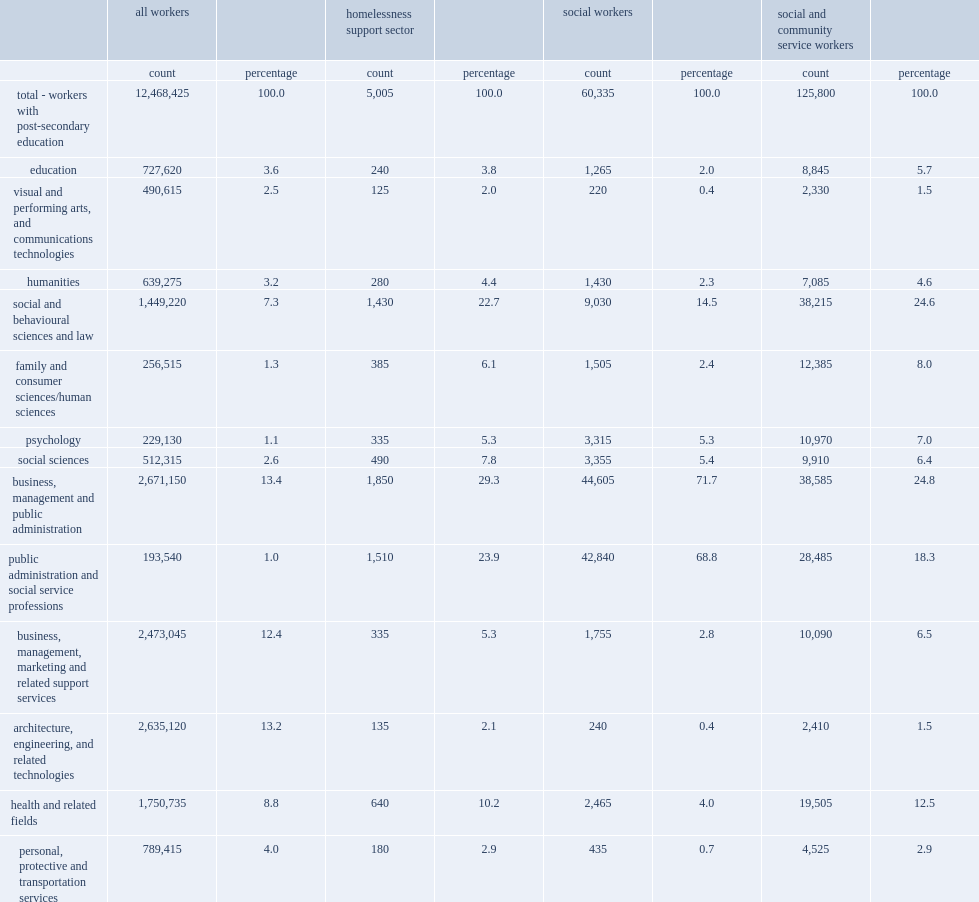How many employees were in homelessness support sector with post-secondary education? 5005.0. What was the proportion of employees in the homelessness support sector that reported their major filed of study as business, management and public administration? 29.3. What was the proportion of employees in the homelessness support sector that reported studying fields related to public administration and social service professions? 23.9. What was the proportion of homelessness support sector workers that reported studying social and behavioural sciences and law? 22.7. What was the proportion of social workers that reported business, management and public administration as their major field of study? 71.7. What was the proportion of social workers that reported social and behavioural sciences and law as their major field of study? 14.5. What was the proportion of social and community service workers reported their major field of study as social and behavioural sciences and law? 24.6. What was the proportion of social and community service workers reported their major field of study as business, management and public administration? 24.8. What was the proportion of social and community service workers reported their major field of study as health and related fields? 12.5. 